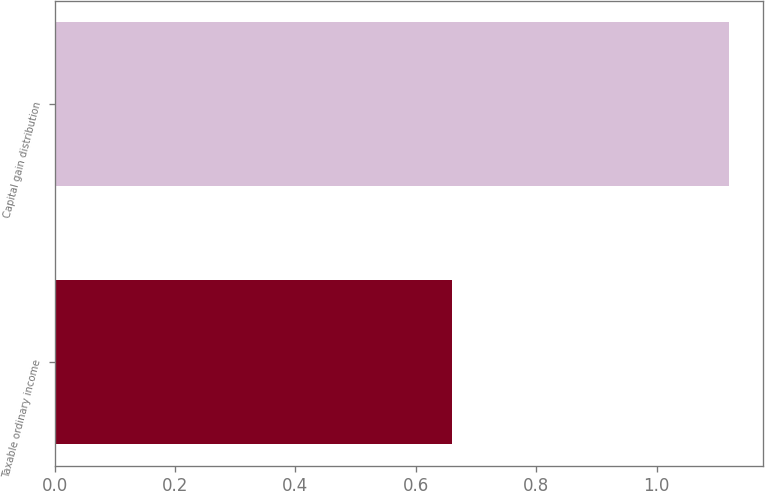<chart> <loc_0><loc_0><loc_500><loc_500><bar_chart><fcel>Taxable ordinary income<fcel>Capital gain distribution<nl><fcel>0.66<fcel>1.12<nl></chart> 